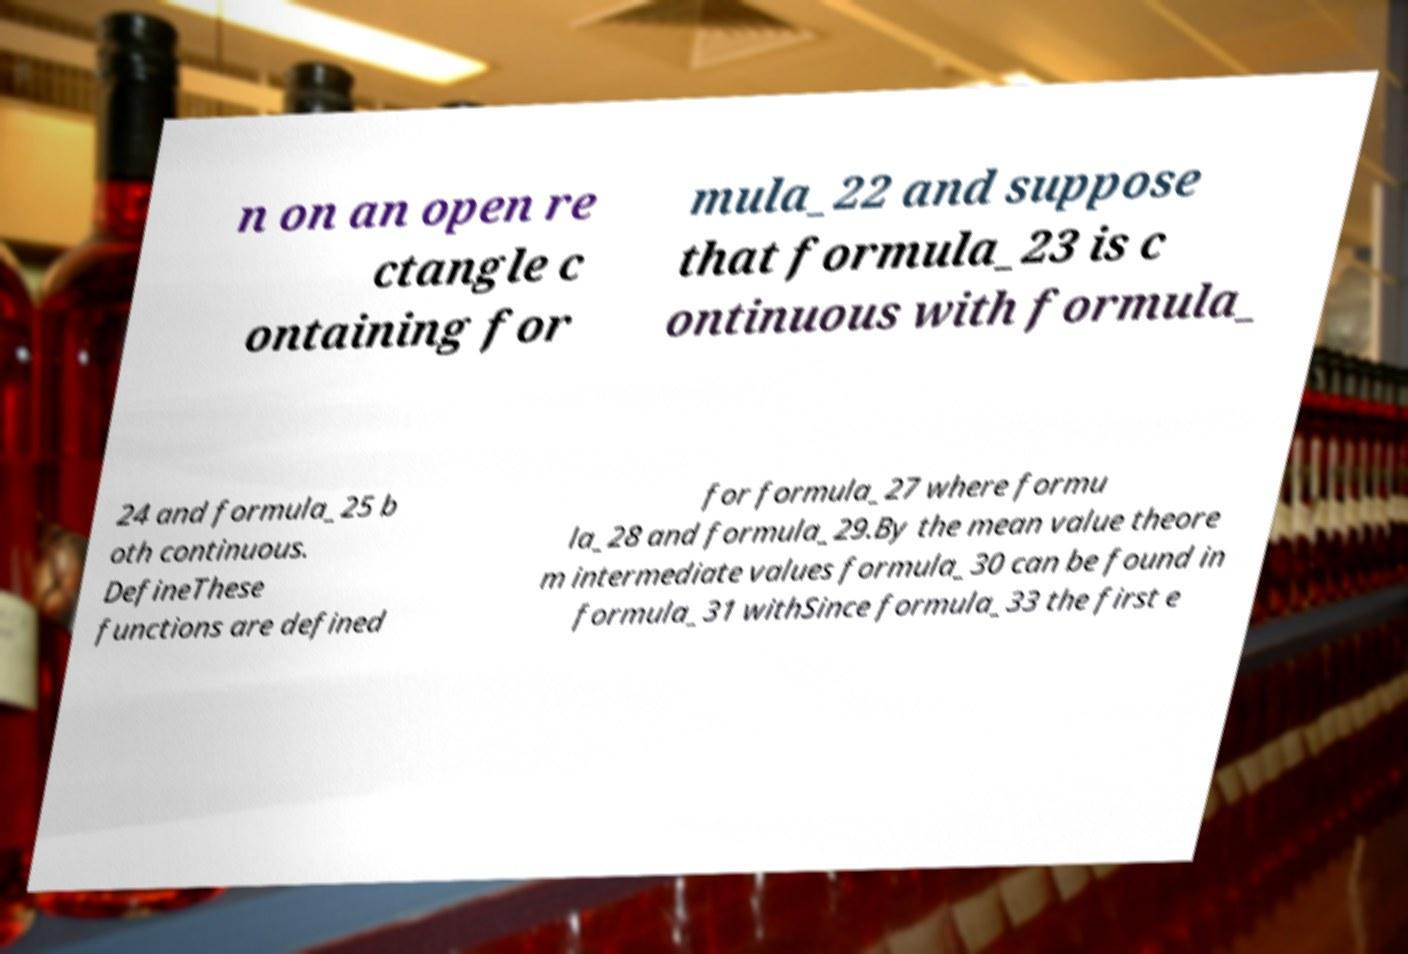Please read and relay the text visible in this image. What does it say? n on an open re ctangle c ontaining for mula_22 and suppose that formula_23 is c ontinuous with formula_ 24 and formula_25 b oth continuous. DefineThese functions are defined for formula_27 where formu la_28 and formula_29.By the mean value theore m intermediate values formula_30 can be found in formula_31 withSince formula_33 the first e 